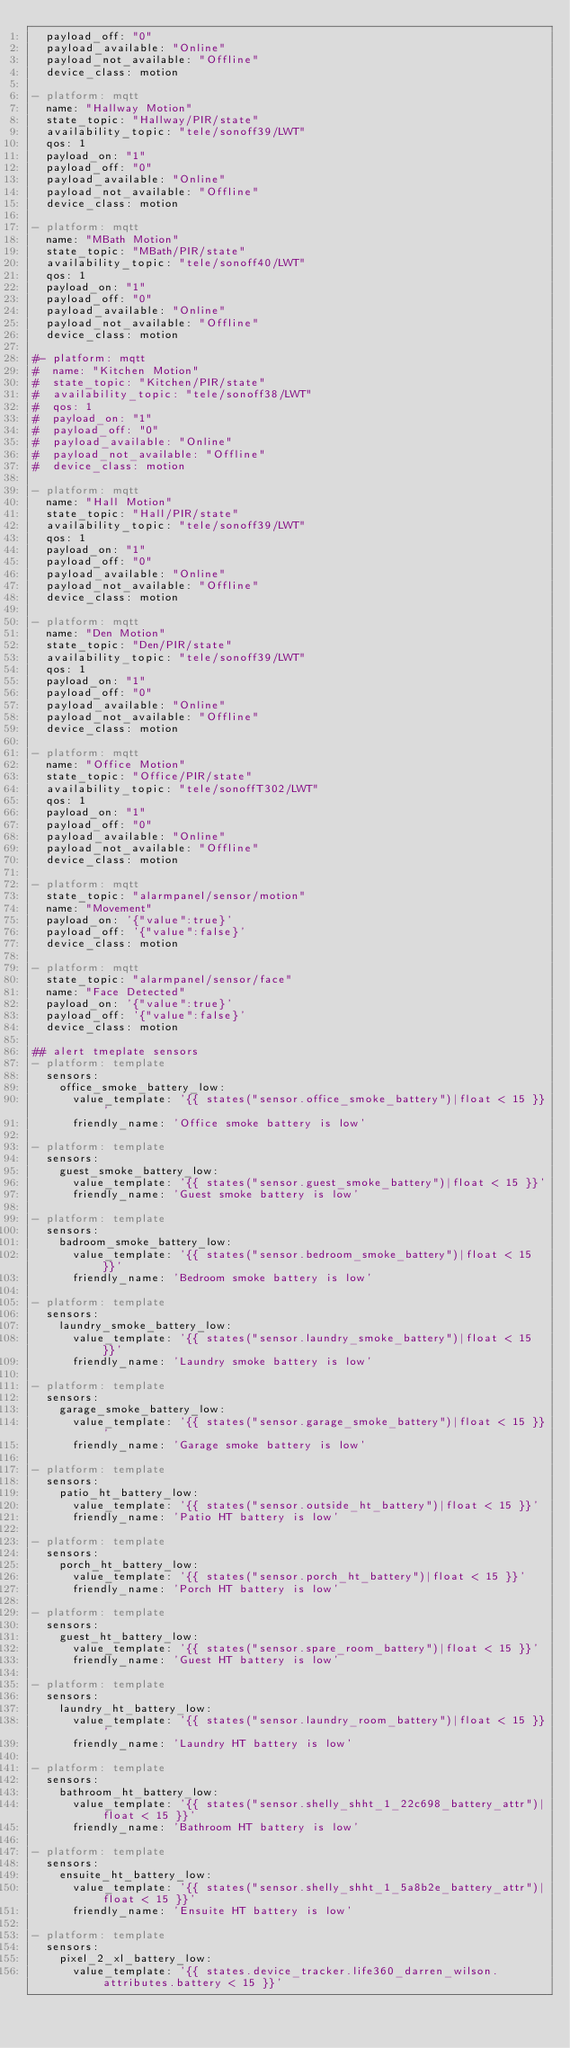Convert code to text. <code><loc_0><loc_0><loc_500><loc_500><_YAML_>  payload_off: "0"
  payload_available: "Online"
  payload_not_available: "Offline"
  device_class: motion

- platform: mqtt
  name: "Hallway Motion"
  state_topic: "Hallway/PIR/state"
  availability_topic: "tele/sonoff39/LWT"
  qos: 1
  payload_on: "1"
  payload_off: "0"
  payload_available: "Online"
  payload_not_available: "Offline"
  device_class: motion

- platform: mqtt
  name: "MBath Motion"
  state_topic: "MBath/PIR/state"
  availability_topic: "tele/sonoff40/LWT"
  qos: 1
  payload_on: "1"
  payload_off: "0"
  payload_available: "Online"
  payload_not_available: "Offline"
  device_class: motion

#- platform: mqtt
#  name: "Kitchen Motion"
#  state_topic: "Kitchen/PIR/state"
#  availability_topic: "tele/sonoff38/LWT"
#  qos: 1
#  payload_on: "1"
#  payload_off: "0"
#  payload_available: "Online"
#  payload_not_available: "Offline"
#  device_class: motion

- platform: mqtt
  name: "Hall Motion"
  state_topic: "Hall/PIR/state"
  availability_topic: "tele/sonoff39/LWT"
  qos: 1
  payload_on: "1"
  payload_off: "0"
  payload_available: "Online"
  payload_not_available: "Offline"
  device_class: motion

- platform: mqtt
  name: "Den Motion"
  state_topic: "Den/PIR/state"
  availability_topic: "tele/sonoff39/LWT"
  qos: 1
  payload_on: "1"
  payload_off: "0"
  payload_available: "Online"
  payload_not_available: "Offline"
  device_class: motion

- platform: mqtt
  name: "Office Motion"
  state_topic: "Office/PIR/state"
  availability_topic: "tele/sonoffT302/LWT"
  qos: 1
  payload_on: "1"
  payload_off: "0"
  payload_available: "Online"
  payload_not_available: "Offline"
  device_class: motion

- platform: mqtt
  state_topic: "alarmpanel/sensor/motion"
  name: "Movement"
  payload_on: '{"value":true}'
  payload_off: '{"value":false}'
  device_class: motion

- platform: mqtt
  state_topic: "alarmpanel/sensor/face"
  name: "Face Detected"
  payload_on: '{"value":true}'
  payload_off: '{"value":false}'
  device_class: motion

## alert tmeplate sensors
- platform: template
  sensors:
    office_smoke_battery_low:
      value_template: '{{ states("sensor.office_smoke_battery")|float < 15 }}'
      friendly_name: 'Office smoke battery is low'

- platform: template
  sensors:
    guest_smoke_battery_low:
      value_template: '{{ states("sensor.guest_smoke_battery")|float < 15 }}'
      friendly_name: 'Guest smoke battery is low'

- platform: template
  sensors:
    badroom_smoke_battery_low:
      value_template: '{{ states("sensor.bedroom_smoke_battery")|float < 15 }}'
      friendly_name: 'Bedroom smoke battery is low'

- platform: template
  sensors:
    laundry_smoke_battery_low:
      value_template: '{{ states("sensor.laundry_smoke_battery")|float < 15 }}'
      friendly_name: 'Laundry smoke battery is low'

- platform: template
  sensors:
    garage_smoke_battery_low:
      value_template: '{{ states("sensor.garage_smoke_battery")|float < 15 }}'
      friendly_name: 'Garage smoke battery is low'

- platform: template
  sensors:
    patio_ht_battery_low:
      value_template: '{{ states("sensor.outside_ht_battery")|float < 15 }}'
      friendly_name: 'Patio HT battery is low'

- platform: template
  sensors:
    porch_ht_battery_low:
      value_template: '{{ states("sensor.porch_ht_battery")|float < 15 }}'
      friendly_name: 'Porch HT battery is low'

- platform: template
  sensors:
    guest_ht_battery_low:
      value_template: '{{ states("sensor.spare_room_battery")|float < 15 }}'
      friendly_name: 'Guest HT battery is low'

- platform: template
  sensors:
    laundry_ht_battery_low:
      value_template: '{{ states("sensor.laundry_room_battery")|float < 15 }}'
      friendly_name: 'Laundry HT battery is low'

- platform: template
  sensors:
    bathroom_ht_battery_low:
      value_template: '{{ states("sensor.shelly_shht_1_22c698_battery_attr")|float < 15 }}'
      friendly_name: 'Bathroom HT battery is low'

- platform: template
  sensors:
    ensuite_ht_battery_low:
      value_template: '{{ states("sensor.shelly_shht_1_5a8b2e_battery_attr")|float < 15 }}'
      friendly_name: 'Ensuite HT battery is low'

- platform: template
  sensors:
    pixel_2_xl_battery_low:
      value_template: '{{ states.device_tracker.life360_darren_wilson.attributes.battery < 15 }}'</code> 